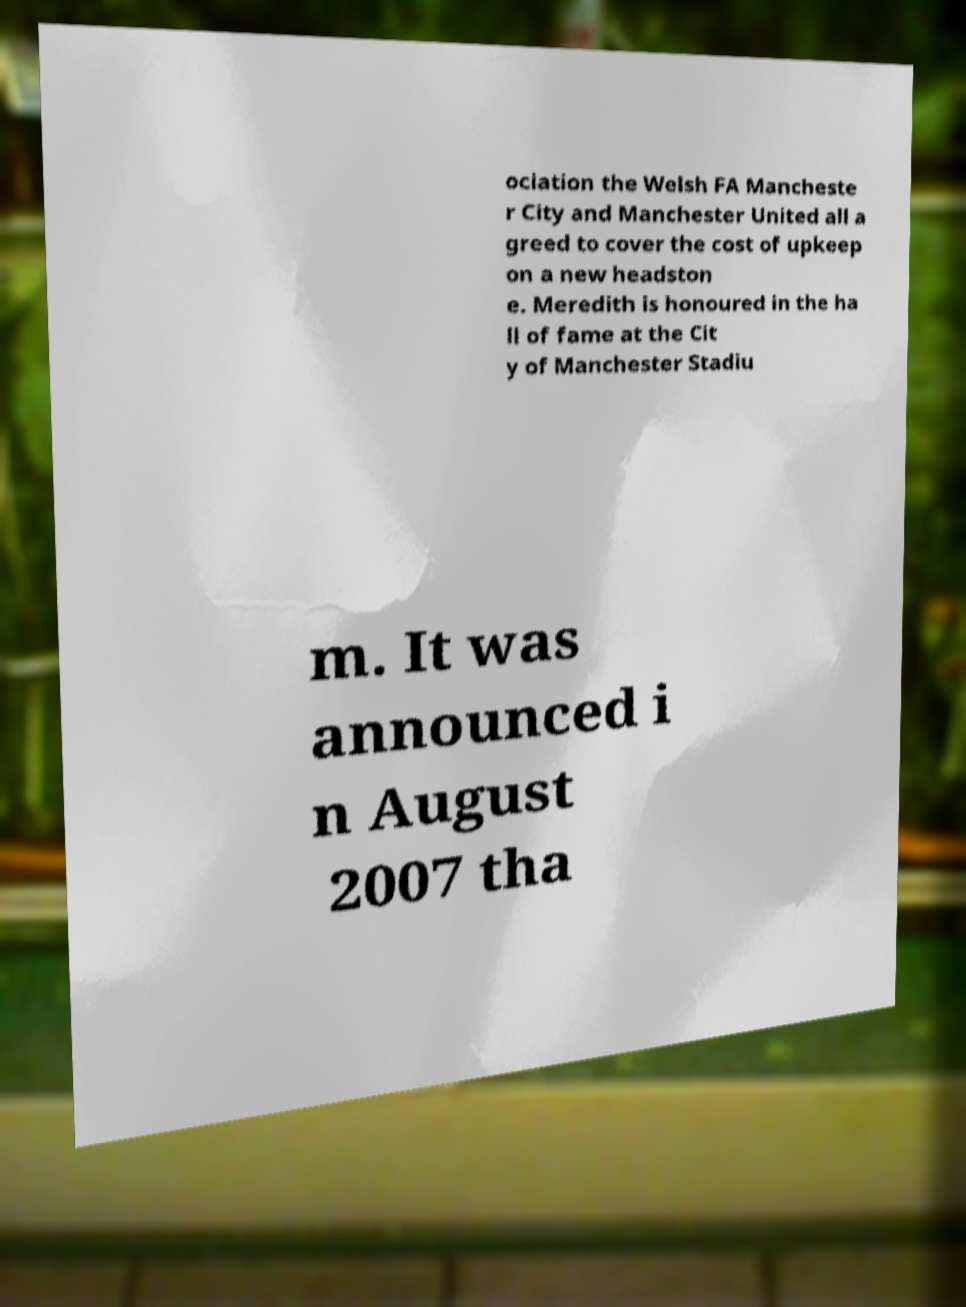There's text embedded in this image that I need extracted. Can you transcribe it verbatim? ociation the Welsh FA Mancheste r City and Manchester United all a greed to cover the cost of upkeep on a new headston e. Meredith is honoured in the ha ll of fame at the Cit y of Manchester Stadiu m. It was announced i n August 2007 tha 